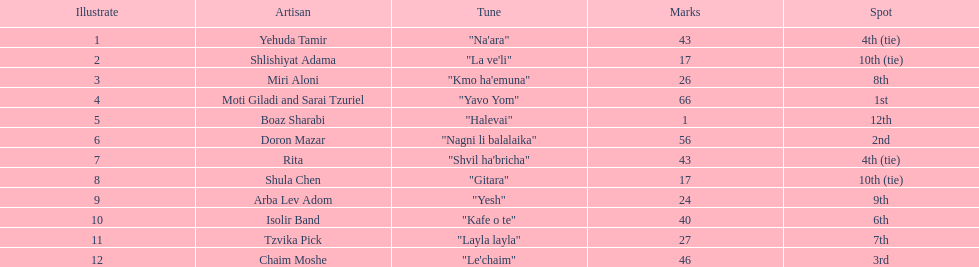What song earned the most points? "Yavo Yom". 